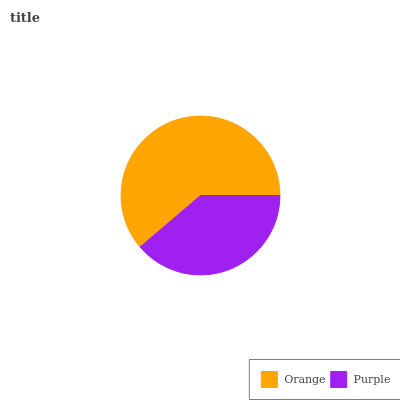Is Purple the minimum?
Answer yes or no. Yes. Is Orange the maximum?
Answer yes or no. Yes. Is Purple the maximum?
Answer yes or no. No. Is Orange greater than Purple?
Answer yes or no. Yes. Is Purple less than Orange?
Answer yes or no. Yes. Is Purple greater than Orange?
Answer yes or no. No. Is Orange less than Purple?
Answer yes or no. No. Is Orange the high median?
Answer yes or no. Yes. Is Purple the low median?
Answer yes or no. Yes. Is Purple the high median?
Answer yes or no. No. Is Orange the low median?
Answer yes or no. No. 